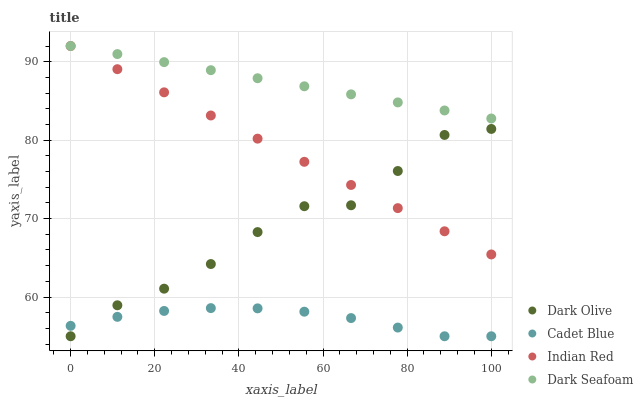Does Cadet Blue have the minimum area under the curve?
Answer yes or no. Yes. Does Dark Seafoam have the maximum area under the curve?
Answer yes or no. Yes. Does Dark Olive have the minimum area under the curve?
Answer yes or no. No. Does Dark Olive have the maximum area under the curve?
Answer yes or no. No. Is Dark Seafoam the smoothest?
Answer yes or no. Yes. Is Dark Olive the roughest?
Answer yes or no. Yes. Is Dark Olive the smoothest?
Answer yes or no. No. Is Dark Seafoam the roughest?
Answer yes or no. No. Does Cadet Blue have the lowest value?
Answer yes or no. Yes. Does Dark Seafoam have the lowest value?
Answer yes or no. No. Does Indian Red have the highest value?
Answer yes or no. Yes. Does Dark Olive have the highest value?
Answer yes or no. No. Is Cadet Blue less than Indian Red?
Answer yes or no. Yes. Is Dark Seafoam greater than Dark Olive?
Answer yes or no. Yes. Does Indian Red intersect Dark Olive?
Answer yes or no. Yes. Is Indian Red less than Dark Olive?
Answer yes or no. No. Is Indian Red greater than Dark Olive?
Answer yes or no. No. Does Cadet Blue intersect Indian Red?
Answer yes or no. No. 